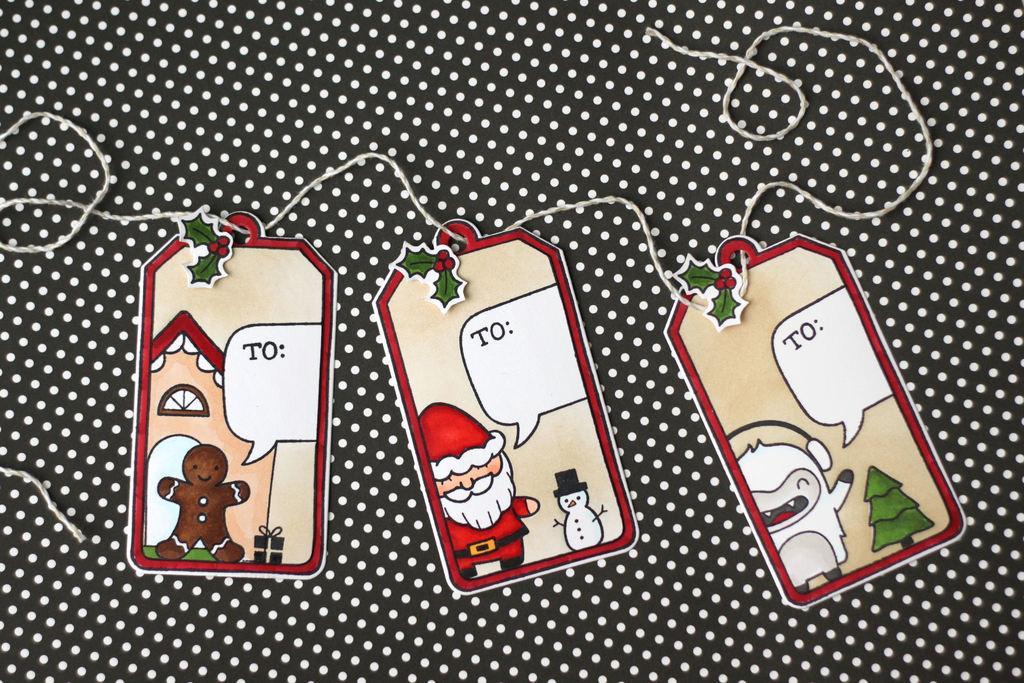How would you summarize this image in a sentence or two? In this image there are tags and a thread on a cloth. 